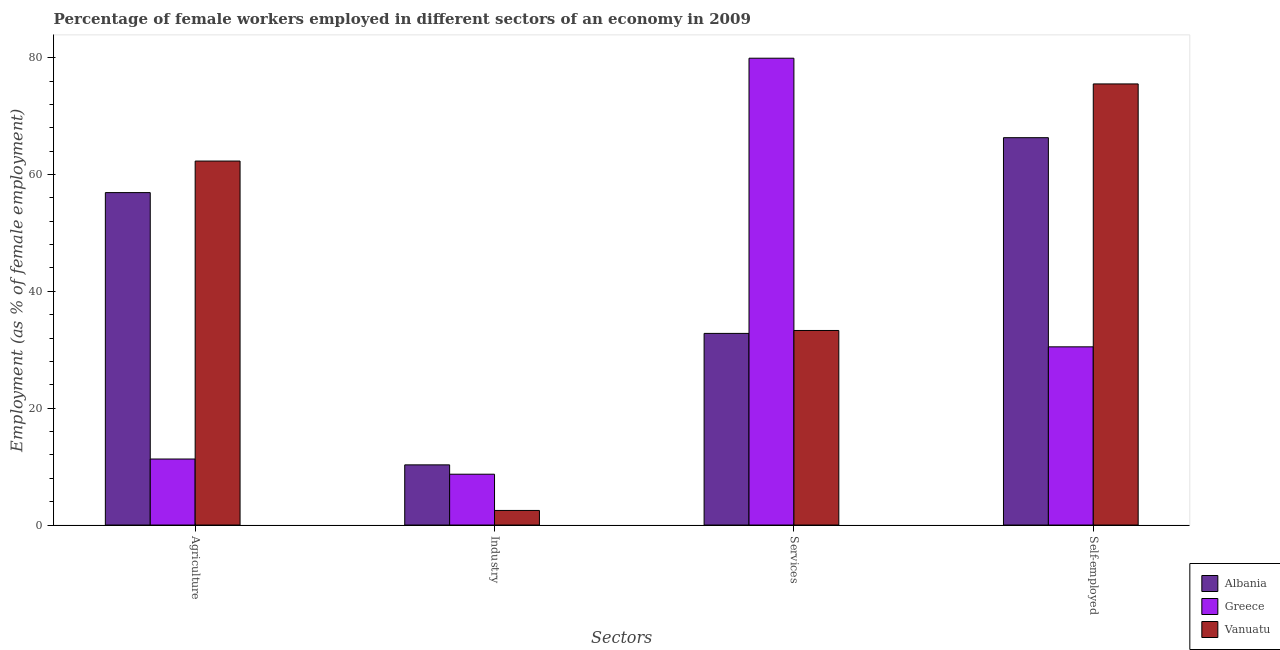How many groups of bars are there?
Provide a short and direct response. 4. Are the number of bars per tick equal to the number of legend labels?
Your response must be concise. Yes. Are the number of bars on each tick of the X-axis equal?
Make the answer very short. Yes. How many bars are there on the 4th tick from the right?
Keep it short and to the point. 3. What is the label of the 4th group of bars from the left?
Your answer should be compact. Self-employed. What is the percentage of female workers in agriculture in Vanuatu?
Provide a short and direct response. 62.3. Across all countries, what is the maximum percentage of female workers in industry?
Offer a very short reply. 10.3. Across all countries, what is the minimum percentage of female workers in services?
Give a very brief answer. 32.8. In which country was the percentage of female workers in agriculture maximum?
Your answer should be very brief. Vanuatu. In which country was the percentage of female workers in services minimum?
Ensure brevity in your answer.  Albania. What is the total percentage of self employed female workers in the graph?
Keep it short and to the point. 172.3. What is the difference between the percentage of self employed female workers in Albania and that in Vanuatu?
Provide a succinct answer. -9.2. What is the difference between the percentage of self employed female workers in Albania and the percentage of female workers in industry in Greece?
Your answer should be very brief. 57.6. What is the average percentage of female workers in agriculture per country?
Ensure brevity in your answer.  43.5. What is the difference between the percentage of female workers in industry and percentage of female workers in services in Albania?
Your answer should be very brief. -22.5. What is the ratio of the percentage of female workers in agriculture in Vanuatu to that in Greece?
Provide a succinct answer. 5.51. What is the difference between the highest and the second highest percentage of female workers in agriculture?
Make the answer very short. 5.4. What is the difference between the highest and the lowest percentage of self employed female workers?
Provide a succinct answer. 45. In how many countries, is the percentage of female workers in services greater than the average percentage of female workers in services taken over all countries?
Provide a short and direct response. 1. What does the 3rd bar from the left in Services represents?
Give a very brief answer. Vanuatu. What does the 2nd bar from the right in Industry represents?
Ensure brevity in your answer.  Greece. Is it the case that in every country, the sum of the percentage of female workers in agriculture and percentage of female workers in industry is greater than the percentage of female workers in services?
Your answer should be compact. No. How many bars are there?
Offer a very short reply. 12. Are the values on the major ticks of Y-axis written in scientific E-notation?
Offer a very short reply. No. Does the graph contain any zero values?
Keep it short and to the point. No. Does the graph contain grids?
Your answer should be compact. No. Where does the legend appear in the graph?
Your response must be concise. Bottom right. How are the legend labels stacked?
Give a very brief answer. Vertical. What is the title of the graph?
Your answer should be compact. Percentage of female workers employed in different sectors of an economy in 2009. Does "Bahrain" appear as one of the legend labels in the graph?
Make the answer very short. No. What is the label or title of the X-axis?
Your response must be concise. Sectors. What is the label or title of the Y-axis?
Your answer should be very brief. Employment (as % of female employment). What is the Employment (as % of female employment) in Albania in Agriculture?
Give a very brief answer. 56.9. What is the Employment (as % of female employment) in Greece in Agriculture?
Provide a short and direct response. 11.3. What is the Employment (as % of female employment) in Vanuatu in Agriculture?
Your response must be concise. 62.3. What is the Employment (as % of female employment) in Albania in Industry?
Make the answer very short. 10.3. What is the Employment (as % of female employment) in Greece in Industry?
Make the answer very short. 8.7. What is the Employment (as % of female employment) in Albania in Services?
Offer a very short reply. 32.8. What is the Employment (as % of female employment) in Greece in Services?
Offer a terse response. 79.9. What is the Employment (as % of female employment) of Vanuatu in Services?
Provide a succinct answer. 33.3. What is the Employment (as % of female employment) of Albania in Self-employed?
Keep it short and to the point. 66.3. What is the Employment (as % of female employment) in Greece in Self-employed?
Your answer should be compact. 30.5. What is the Employment (as % of female employment) of Vanuatu in Self-employed?
Your answer should be very brief. 75.5. Across all Sectors, what is the maximum Employment (as % of female employment) of Albania?
Your answer should be compact. 66.3. Across all Sectors, what is the maximum Employment (as % of female employment) in Greece?
Your answer should be compact. 79.9. Across all Sectors, what is the maximum Employment (as % of female employment) of Vanuatu?
Make the answer very short. 75.5. Across all Sectors, what is the minimum Employment (as % of female employment) in Albania?
Your response must be concise. 10.3. Across all Sectors, what is the minimum Employment (as % of female employment) of Greece?
Ensure brevity in your answer.  8.7. What is the total Employment (as % of female employment) of Albania in the graph?
Offer a terse response. 166.3. What is the total Employment (as % of female employment) of Greece in the graph?
Your response must be concise. 130.4. What is the total Employment (as % of female employment) in Vanuatu in the graph?
Your response must be concise. 173.6. What is the difference between the Employment (as % of female employment) in Albania in Agriculture and that in Industry?
Your response must be concise. 46.6. What is the difference between the Employment (as % of female employment) in Vanuatu in Agriculture and that in Industry?
Your answer should be very brief. 59.8. What is the difference between the Employment (as % of female employment) in Albania in Agriculture and that in Services?
Give a very brief answer. 24.1. What is the difference between the Employment (as % of female employment) of Greece in Agriculture and that in Services?
Offer a very short reply. -68.6. What is the difference between the Employment (as % of female employment) in Vanuatu in Agriculture and that in Services?
Your answer should be very brief. 29. What is the difference between the Employment (as % of female employment) of Greece in Agriculture and that in Self-employed?
Make the answer very short. -19.2. What is the difference between the Employment (as % of female employment) in Vanuatu in Agriculture and that in Self-employed?
Keep it short and to the point. -13.2. What is the difference between the Employment (as % of female employment) in Albania in Industry and that in Services?
Provide a succinct answer. -22.5. What is the difference between the Employment (as % of female employment) of Greece in Industry and that in Services?
Offer a terse response. -71.2. What is the difference between the Employment (as % of female employment) of Vanuatu in Industry and that in Services?
Give a very brief answer. -30.8. What is the difference between the Employment (as % of female employment) of Albania in Industry and that in Self-employed?
Provide a short and direct response. -56. What is the difference between the Employment (as % of female employment) of Greece in Industry and that in Self-employed?
Keep it short and to the point. -21.8. What is the difference between the Employment (as % of female employment) of Vanuatu in Industry and that in Self-employed?
Make the answer very short. -73. What is the difference between the Employment (as % of female employment) of Albania in Services and that in Self-employed?
Provide a short and direct response. -33.5. What is the difference between the Employment (as % of female employment) in Greece in Services and that in Self-employed?
Give a very brief answer. 49.4. What is the difference between the Employment (as % of female employment) of Vanuatu in Services and that in Self-employed?
Offer a very short reply. -42.2. What is the difference between the Employment (as % of female employment) of Albania in Agriculture and the Employment (as % of female employment) of Greece in Industry?
Your response must be concise. 48.2. What is the difference between the Employment (as % of female employment) of Albania in Agriculture and the Employment (as % of female employment) of Vanuatu in Industry?
Your answer should be compact. 54.4. What is the difference between the Employment (as % of female employment) of Greece in Agriculture and the Employment (as % of female employment) of Vanuatu in Industry?
Keep it short and to the point. 8.8. What is the difference between the Employment (as % of female employment) of Albania in Agriculture and the Employment (as % of female employment) of Greece in Services?
Ensure brevity in your answer.  -23. What is the difference between the Employment (as % of female employment) of Albania in Agriculture and the Employment (as % of female employment) of Vanuatu in Services?
Your response must be concise. 23.6. What is the difference between the Employment (as % of female employment) in Albania in Agriculture and the Employment (as % of female employment) in Greece in Self-employed?
Make the answer very short. 26.4. What is the difference between the Employment (as % of female employment) of Albania in Agriculture and the Employment (as % of female employment) of Vanuatu in Self-employed?
Give a very brief answer. -18.6. What is the difference between the Employment (as % of female employment) of Greece in Agriculture and the Employment (as % of female employment) of Vanuatu in Self-employed?
Your answer should be very brief. -64.2. What is the difference between the Employment (as % of female employment) of Albania in Industry and the Employment (as % of female employment) of Greece in Services?
Your answer should be compact. -69.6. What is the difference between the Employment (as % of female employment) in Albania in Industry and the Employment (as % of female employment) in Vanuatu in Services?
Your response must be concise. -23. What is the difference between the Employment (as % of female employment) in Greece in Industry and the Employment (as % of female employment) in Vanuatu in Services?
Your answer should be compact. -24.6. What is the difference between the Employment (as % of female employment) in Albania in Industry and the Employment (as % of female employment) in Greece in Self-employed?
Ensure brevity in your answer.  -20.2. What is the difference between the Employment (as % of female employment) in Albania in Industry and the Employment (as % of female employment) in Vanuatu in Self-employed?
Your answer should be very brief. -65.2. What is the difference between the Employment (as % of female employment) of Greece in Industry and the Employment (as % of female employment) of Vanuatu in Self-employed?
Keep it short and to the point. -66.8. What is the difference between the Employment (as % of female employment) of Albania in Services and the Employment (as % of female employment) of Greece in Self-employed?
Give a very brief answer. 2.3. What is the difference between the Employment (as % of female employment) in Albania in Services and the Employment (as % of female employment) in Vanuatu in Self-employed?
Give a very brief answer. -42.7. What is the average Employment (as % of female employment) of Albania per Sectors?
Your response must be concise. 41.58. What is the average Employment (as % of female employment) in Greece per Sectors?
Provide a short and direct response. 32.6. What is the average Employment (as % of female employment) of Vanuatu per Sectors?
Offer a very short reply. 43.4. What is the difference between the Employment (as % of female employment) in Albania and Employment (as % of female employment) in Greece in Agriculture?
Provide a succinct answer. 45.6. What is the difference between the Employment (as % of female employment) in Albania and Employment (as % of female employment) in Vanuatu in Agriculture?
Provide a succinct answer. -5.4. What is the difference between the Employment (as % of female employment) of Greece and Employment (as % of female employment) of Vanuatu in Agriculture?
Your answer should be compact. -51. What is the difference between the Employment (as % of female employment) in Albania and Employment (as % of female employment) in Greece in Industry?
Your answer should be compact. 1.6. What is the difference between the Employment (as % of female employment) of Greece and Employment (as % of female employment) of Vanuatu in Industry?
Your response must be concise. 6.2. What is the difference between the Employment (as % of female employment) in Albania and Employment (as % of female employment) in Greece in Services?
Keep it short and to the point. -47.1. What is the difference between the Employment (as % of female employment) in Albania and Employment (as % of female employment) in Vanuatu in Services?
Give a very brief answer. -0.5. What is the difference between the Employment (as % of female employment) of Greece and Employment (as % of female employment) of Vanuatu in Services?
Offer a terse response. 46.6. What is the difference between the Employment (as % of female employment) in Albania and Employment (as % of female employment) in Greece in Self-employed?
Provide a succinct answer. 35.8. What is the difference between the Employment (as % of female employment) of Greece and Employment (as % of female employment) of Vanuatu in Self-employed?
Your response must be concise. -45. What is the ratio of the Employment (as % of female employment) of Albania in Agriculture to that in Industry?
Offer a terse response. 5.52. What is the ratio of the Employment (as % of female employment) in Greece in Agriculture to that in Industry?
Provide a short and direct response. 1.3. What is the ratio of the Employment (as % of female employment) in Vanuatu in Agriculture to that in Industry?
Your answer should be compact. 24.92. What is the ratio of the Employment (as % of female employment) in Albania in Agriculture to that in Services?
Keep it short and to the point. 1.73. What is the ratio of the Employment (as % of female employment) in Greece in Agriculture to that in Services?
Your answer should be compact. 0.14. What is the ratio of the Employment (as % of female employment) of Vanuatu in Agriculture to that in Services?
Provide a succinct answer. 1.87. What is the ratio of the Employment (as % of female employment) in Albania in Agriculture to that in Self-employed?
Keep it short and to the point. 0.86. What is the ratio of the Employment (as % of female employment) in Greece in Agriculture to that in Self-employed?
Offer a very short reply. 0.37. What is the ratio of the Employment (as % of female employment) of Vanuatu in Agriculture to that in Self-employed?
Make the answer very short. 0.83. What is the ratio of the Employment (as % of female employment) in Albania in Industry to that in Services?
Provide a short and direct response. 0.31. What is the ratio of the Employment (as % of female employment) of Greece in Industry to that in Services?
Your response must be concise. 0.11. What is the ratio of the Employment (as % of female employment) of Vanuatu in Industry to that in Services?
Provide a short and direct response. 0.08. What is the ratio of the Employment (as % of female employment) in Albania in Industry to that in Self-employed?
Ensure brevity in your answer.  0.16. What is the ratio of the Employment (as % of female employment) in Greece in Industry to that in Self-employed?
Your answer should be compact. 0.29. What is the ratio of the Employment (as % of female employment) of Vanuatu in Industry to that in Self-employed?
Provide a short and direct response. 0.03. What is the ratio of the Employment (as % of female employment) in Albania in Services to that in Self-employed?
Your answer should be compact. 0.49. What is the ratio of the Employment (as % of female employment) in Greece in Services to that in Self-employed?
Provide a short and direct response. 2.62. What is the ratio of the Employment (as % of female employment) in Vanuatu in Services to that in Self-employed?
Give a very brief answer. 0.44. What is the difference between the highest and the second highest Employment (as % of female employment) of Greece?
Ensure brevity in your answer.  49.4. What is the difference between the highest and the second highest Employment (as % of female employment) of Vanuatu?
Keep it short and to the point. 13.2. What is the difference between the highest and the lowest Employment (as % of female employment) in Greece?
Give a very brief answer. 71.2. What is the difference between the highest and the lowest Employment (as % of female employment) in Vanuatu?
Give a very brief answer. 73. 